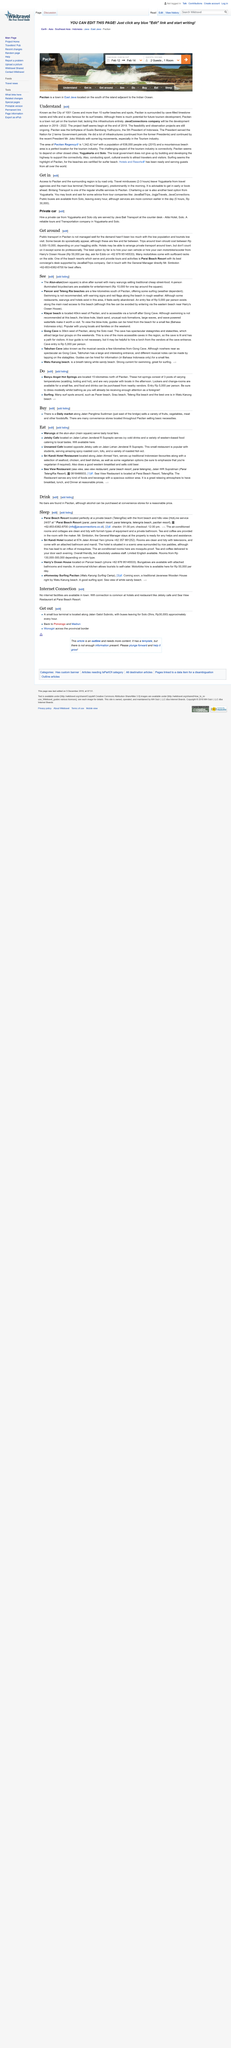Outline some significant characteristics in this image. JavaConnections company will serve as the development advisor from 2019-2022. The title of the article is 'Understanding the Importance of Sustainability in the Global Economy'. Pacitan is renowned for its status as the "City of 1001 Caves" and its distinction of having more than ten surfer beaches and spots. 